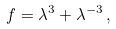<formula> <loc_0><loc_0><loc_500><loc_500>f = \lambda ^ { 3 } + \lambda ^ { - 3 } \, ,</formula> 